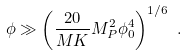Convert formula to latex. <formula><loc_0><loc_0><loc_500><loc_500>\phi \gg \left ( \frac { 2 0 } { M K } M _ { P } ^ { 2 } \phi _ { 0 } ^ { 4 } \right ) ^ { 1 / 6 } \ .</formula> 